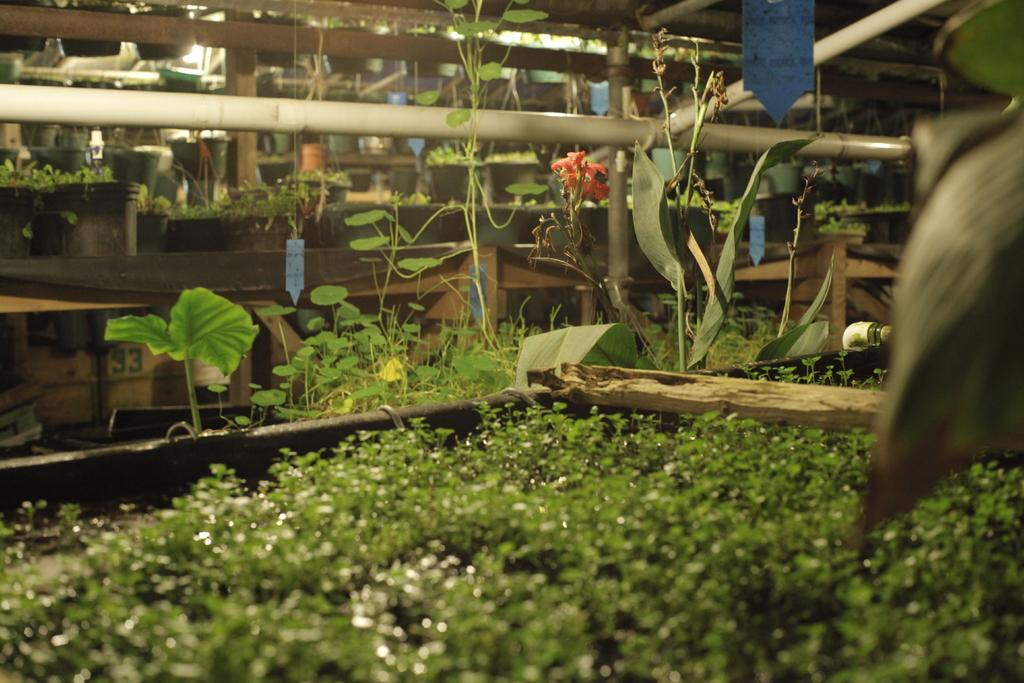What type of living organisms can be seen in the image? Plants can be seen in the image. What objects are present in the image that might be used to hold or grow the plants? Pots are present in the image. Can you see a snail crawling on the plants in the image? There is no snail visible in the image. What type of cable is connected to the plants in the image? There is no cable connected to the plants in the image. 